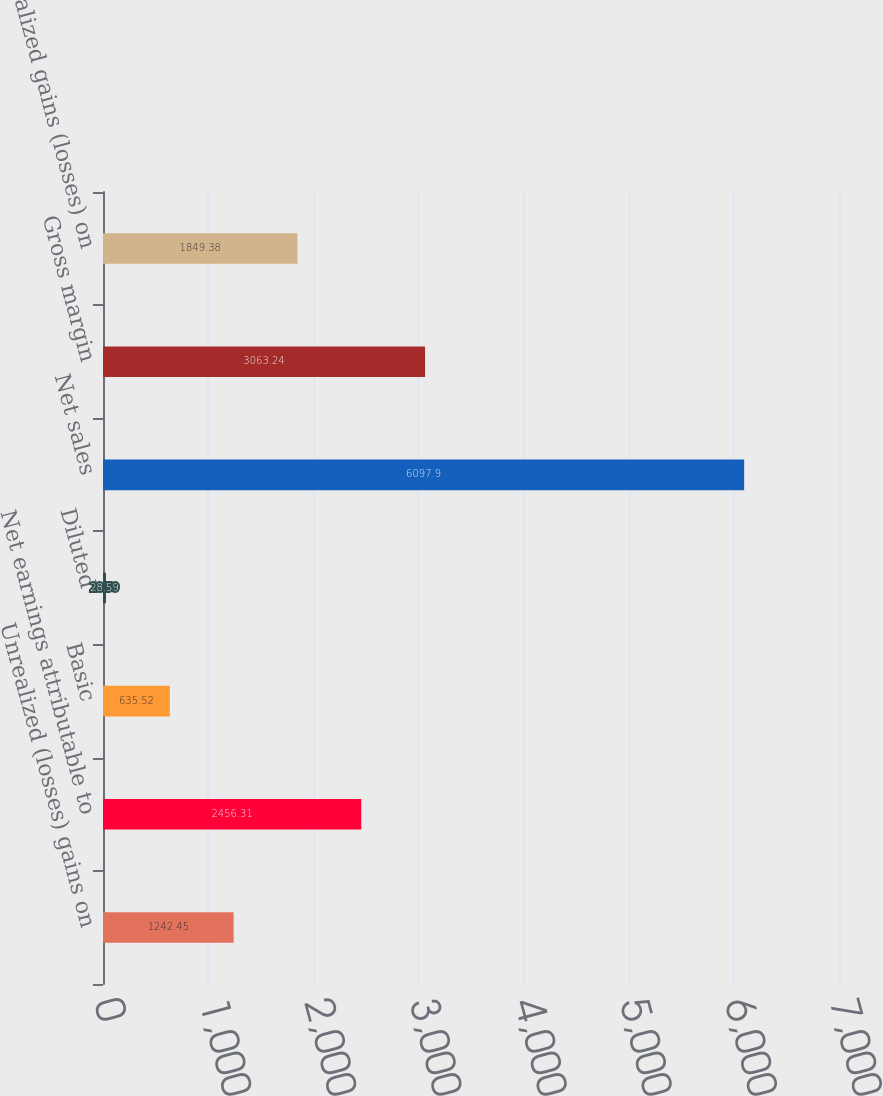<chart> <loc_0><loc_0><loc_500><loc_500><bar_chart><fcel>Unrealized (losses) gains on<fcel>Net earnings attributable to<fcel>Basic<fcel>Diluted<fcel>Net sales<fcel>Gross margin<fcel>Unrealized gains (losses) on<nl><fcel>1242.45<fcel>2456.31<fcel>635.52<fcel>28.59<fcel>6097.9<fcel>3063.24<fcel>1849.38<nl></chart> 